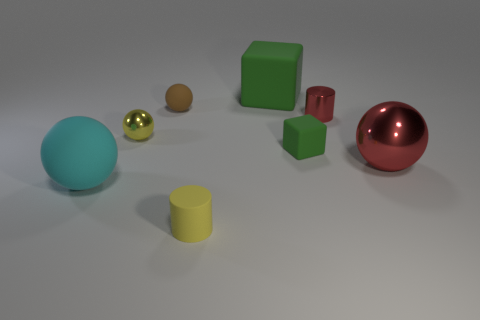Add 2 big green objects. How many objects exist? 10 Subtract all green balls. Subtract all blue blocks. How many balls are left? 4 Subtract all blocks. How many objects are left? 6 Add 7 brown balls. How many brown balls exist? 8 Subtract 0 purple spheres. How many objects are left? 8 Subtract all yellow cylinders. Subtract all cyan matte balls. How many objects are left? 6 Add 4 brown balls. How many brown balls are left? 5 